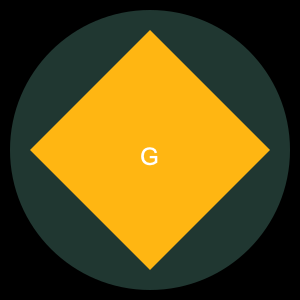What is the approximate ratio of the yellow diamond's width to the green circle's diameter in the Green Bay Packers' logo? To determine the ratio of the yellow diamond's width to the green circle's diameter:

1. Observe that the diamond is inscribed within the circle.
2. The diamond's width spans from the left point to the right point, which is equal to the circle's diameter.
3. The circle's diameter is 280 units (radius is 140).
4. The diamond's width is also 280 units.
5. Calculate the ratio:
   $$ \text{Ratio} = \frac{\text{Diamond Width}}{\text{Circle Diameter}} = \frac{280}{280} = 1 $$

Therefore, the ratio of the yellow diamond's width to the green circle's diameter is approximately 1:1.
Answer: 1:1 